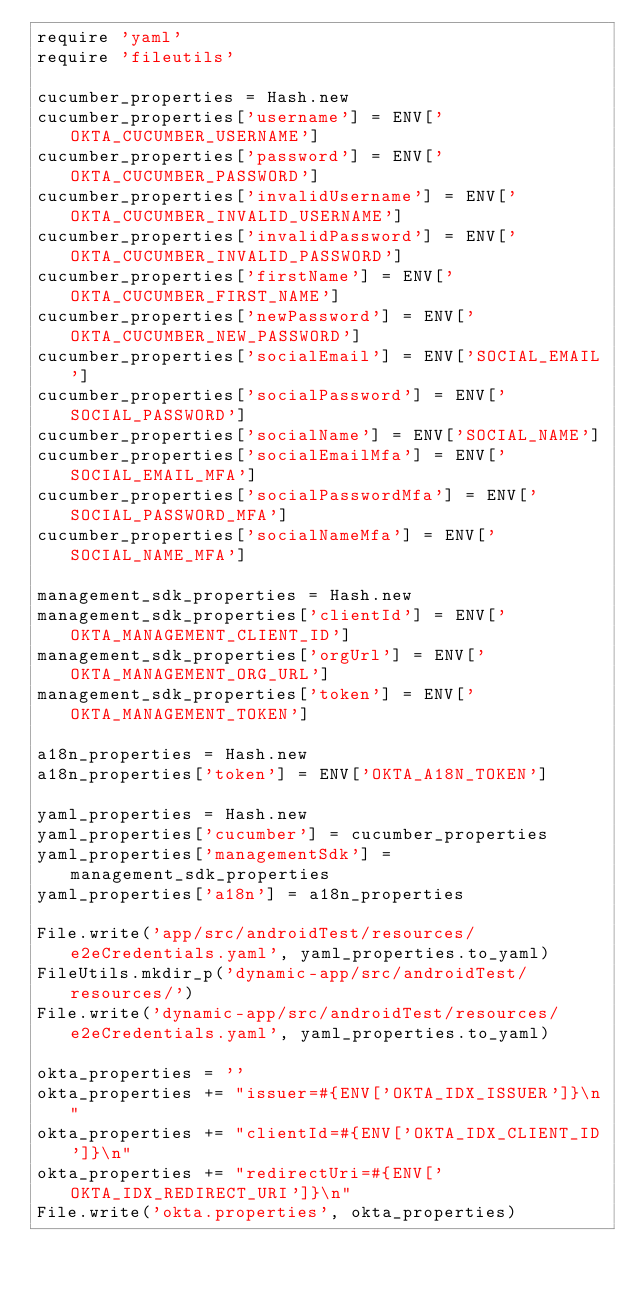<code> <loc_0><loc_0><loc_500><loc_500><_Ruby_>require 'yaml'
require 'fileutils'

cucumber_properties = Hash.new
cucumber_properties['username'] = ENV['OKTA_CUCUMBER_USERNAME']
cucumber_properties['password'] = ENV['OKTA_CUCUMBER_PASSWORD']
cucumber_properties['invalidUsername'] = ENV['OKTA_CUCUMBER_INVALID_USERNAME']
cucumber_properties['invalidPassword'] = ENV['OKTA_CUCUMBER_INVALID_PASSWORD']
cucumber_properties['firstName'] = ENV['OKTA_CUCUMBER_FIRST_NAME']
cucumber_properties['newPassword'] = ENV['OKTA_CUCUMBER_NEW_PASSWORD']
cucumber_properties['socialEmail'] = ENV['SOCIAL_EMAIL']
cucumber_properties['socialPassword'] = ENV['SOCIAL_PASSWORD']
cucumber_properties['socialName'] = ENV['SOCIAL_NAME']
cucumber_properties['socialEmailMfa'] = ENV['SOCIAL_EMAIL_MFA']
cucumber_properties['socialPasswordMfa'] = ENV['SOCIAL_PASSWORD_MFA']
cucumber_properties['socialNameMfa'] = ENV['SOCIAL_NAME_MFA']

management_sdk_properties = Hash.new
management_sdk_properties['clientId'] = ENV['OKTA_MANAGEMENT_CLIENT_ID']
management_sdk_properties['orgUrl'] = ENV['OKTA_MANAGEMENT_ORG_URL']
management_sdk_properties['token'] = ENV['OKTA_MANAGEMENT_TOKEN']

a18n_properties = Hash.new
a18n_properties['token'] = ENV['OKTA_A18N_TOKEN']

yaml_properties = Hash.new
yaml_properties['cucumber'] = cucumber_properties
yaml_properties['managementSdk'] = management_sdk_properties
yaml_properties['a18n'] = a18n_properties

File.write('app/src/androidTest/resources/e2eCredentials.yaml', yaml_properties.to_yaml)
FileUtils.mkdir_p('dynamic-app/src/androidTest/resources/')
File.write('dynamic-app/src/androidTest/resources/e2eCredentials.yaml', yaml_properties.to_yaml)

okta_properties = ''
okta_properties += "issuer=#{ENV['OKTA_IDX_ISSUER']}\n"
okta_properties += "clientId=#{ENV['OKTA_IDX_CLIENT_ID']}\n"
okta_properties += "redirectUri=#{ENV['OKTA_IDX_REDIRECT_URI']}\n"
File.write('okta.properties', okta_properties)
</code> 